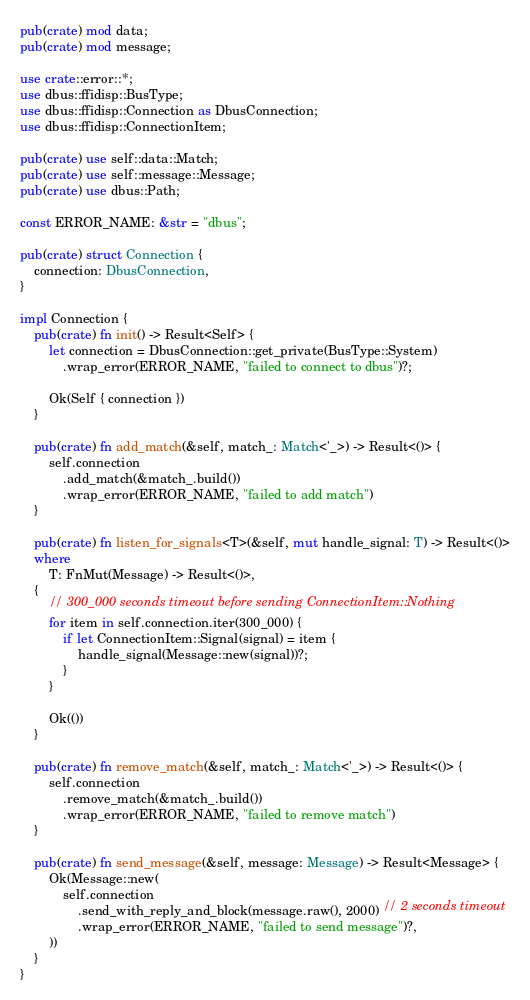Convert code to text. <code><loc_0><loc_0><loc_500><loc_500><_Rust_>pub(crate) mod data;
pub(crate) mod message;

use crate::error::*;
use dbus::ffidisp::BusType;
use dbus::ffidisp::Connection as DbusConnection;
use dbus::ffidisp::ConnectionItem;

pub(crate) use self::data::Match;
pub(crate) use self::message::Message;
pub(crate) use dbus::Path;

const ERROR_NAME: &str = "dbus";

pub(crate) struct Connection {
    connection: DbusConnection,
}

impl Connection {
    pub(crate) fn init() -> Result<Self> {
        let connection = DbusConnection::get_private(BusType::System)
            .wrap_error(ERROR_NAME, "failed to connect to dbus")?;

        Ok(Self { connection })
    }

    pub(crate) fn add_match(&self, match_: Match<'_>) -> Result<()> {
        self.connection
            .add_match(&match_.build())
            .wrap_error(ERROR_NAME, "failed to add match")
    }

    pub(crate) fn listen_for_signals<T>(&self, mut handle_signal: T) -> Result<()>
    where
        T: FnMut(Message) -> Result<()>,
    {
        // 300_000 seconds timeout before sending ConnectionItem::Nothing
        for item in self.connection.iter(300_000) {
            if let ConnectionItem::Signal(signal) = item {
                handle_signal(Message::new(signal))?;
            }
        }

        Ok(())
    }

    pub(crate) fn remove_match(&self, match_: Match<'_>) -> Result<()> {
        self.connection
            .remove_match(&match_.build())
            .wrap_error(ERROR_NAME, "failed to remove match")
    }

    pub(crate) fn send_message(&self, message: Message) -> Result<Message> {
        Ok(Message::new(
            self.connection
                .send_with_reply_and_block(message.raw(), 2000) // 2 seconds timeout
                .wrap_error(ERROR_NAME, "failed to send message")?,
        ))
    }
}
</code> 